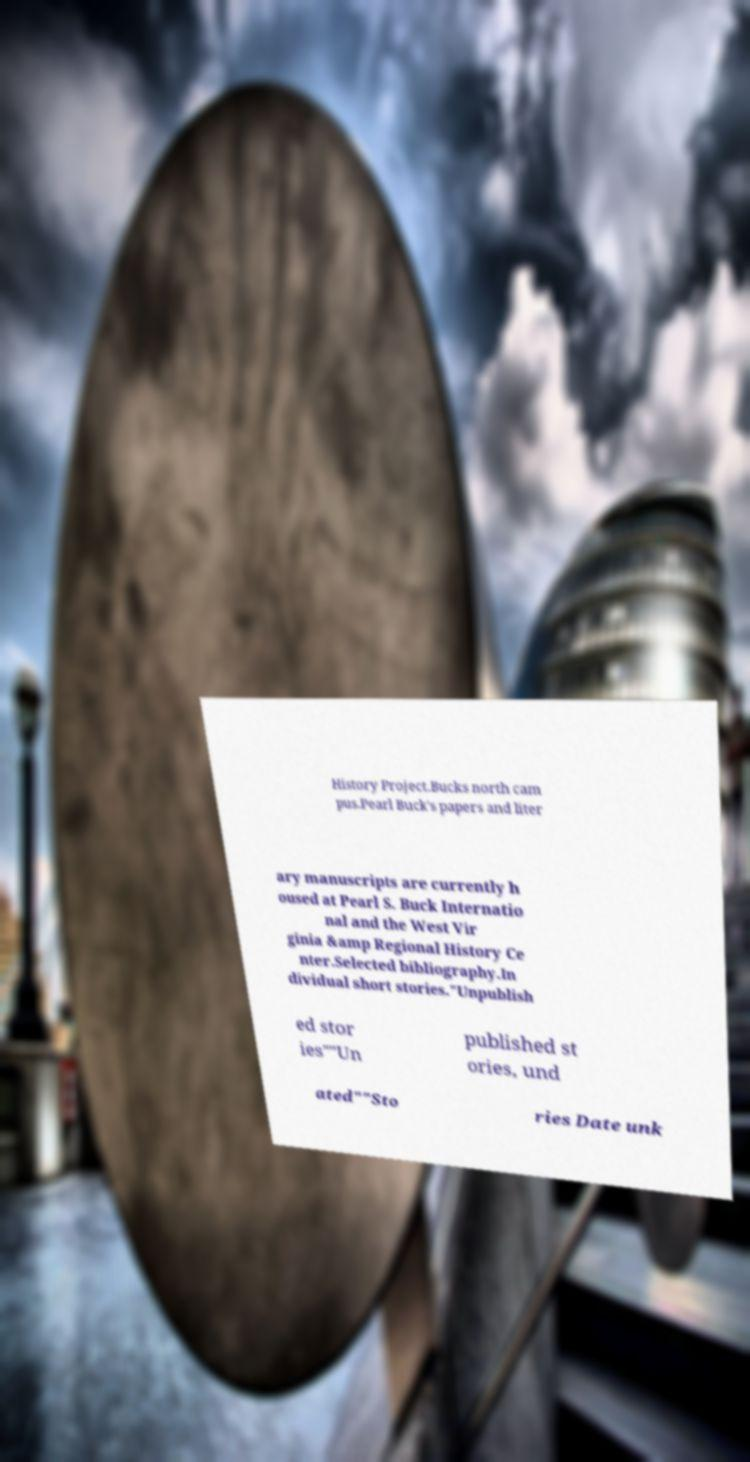Could you assist in decoding the text presented in this image and type it out clearly? History Project.Bucks north cam pus.Pearl Buck's papers and liter ary manuscripts are currently h oused at Pearl S. Buck Internatio nal and the West Vir ginia &amp Regional History Ce nter.Selected bibliography.In dividual short stories."Unpublish ed stor ies""Un published st ories, und ated""Sto ries Date unk 